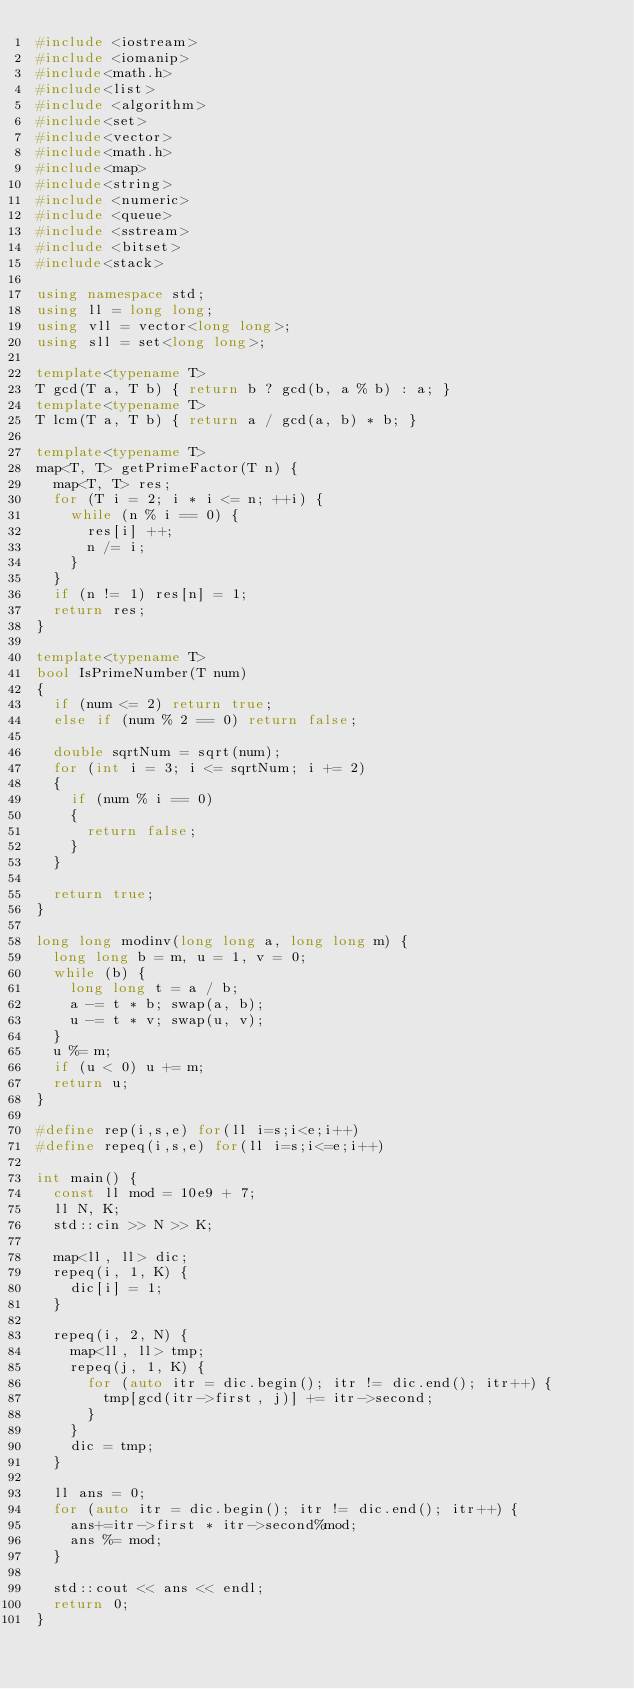Convert code to text. <code><loc_0><loc_0><loc_500><loc_500><_C++_>#include <iostream>
#include <iomanip>
#include<math.h>
#include<list>
#include <algorithm>
#include<set>
#include<vector>
#include<math.h>
#include<map>
#include<string>
#include <numeric>
#include <queue>
#include <sstream>
#include <bitset>
#include<stack>

using namespace std;
using ll = long long;
using vll = vector<long long>;
using sll = set<long long>;

template<typename T>
T gcd(T a, T b) { return b ? gcd(b, a % b) : a; }
template<typename T>
T lcm(T a, T b) { return a / gcd(a, b) * b; }

template<typename T>
map<T, T> getPrimeFactor(T n) {
	map<T, T> res;
	for (T i = 2; i * i <= n; ++i) {
		while (n % i == 0) {
			res[i] ++;
			n /= i;
		}
	}
	if (n != 1) res[n] = 1;
	return res;
}

template<typename T>
bool IsPrimeNumber(T num)
{
	if (num <= 2) return true;
	else if (num % 2 == 0) return false;

	double sqrtNum = sqrt(num);
	for (int i = 3; i <= sqrtNum; i += 2)
	{
		if (num % i == 0)
		{
			return false;
		}
	}

	return true;
}

long long modinv(long long a, long long m) {
	long long b = m, u = 1, v = 0;
	while (b) {
		long long t = a / b;
		a -= t * b; swap(a, b);
		u -= t * v; swap(u, v);
	}
	u %= m;
	if (u < 0) u += m;
	return u;
}

#define rep(i,s,e) for(ll i=s;i<e;i++)
#define repeq(i,s,e) for(ll i=s;i<=e;i++)

int main() {
	const ll mod = 10e9 + 7;
	ll N, K;
	std::cin >> N >> K;

	map<ll, ll> dic;
	repeq(i, 1, K) {
		dic[i] = 1;
	}
	
	repeq(i, 2, N) {
		map<ll, ll> tmp;
		repeq(j, 1, K) {
			for (auto itr = dic.begin(); itr != dic.end(); itr++) {
				tmp[gcd(itr->first, j)] += itr->second;
			}
		}
		dic = tmp;
	}

	ll ans = 0;
	for (auto itr = dic.begin(); itr != dic.end(); itr++) {
		ans+=itr->first * itr->second%mod;
		ans %= mod;
	}

	std::cout << ans << endl;
	return 0;
}
</code> 